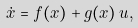<formula> <loc_0><loc_0><loc_500><loc_500>\dot { x } & = f ( x ) + g ( x ) \, u ,</formula> 